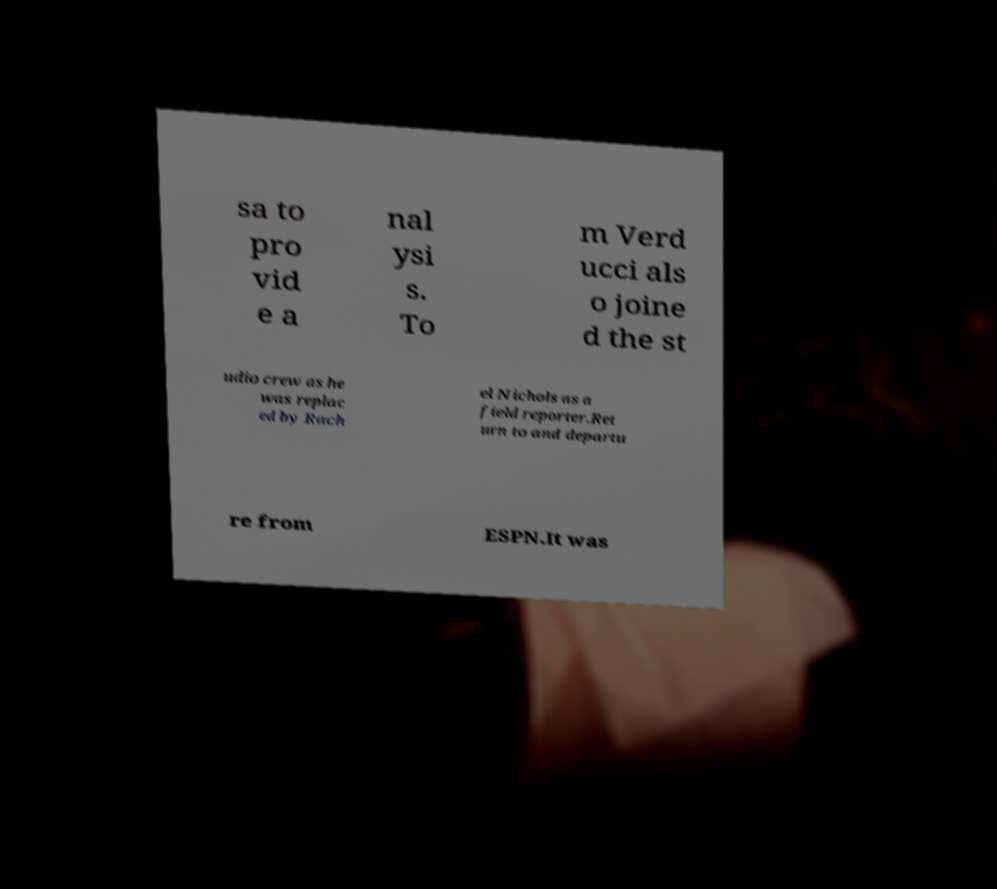For documentation purposes, I need the text within this image transcribed. Could you provide that? sa to pro vid e a nal ysi s. To m Verd ucci als o joine d the st udio crew as he was replac ed by Rach el Nichols as a field reporter.Ret urn to and departu re from ESPN.It was 